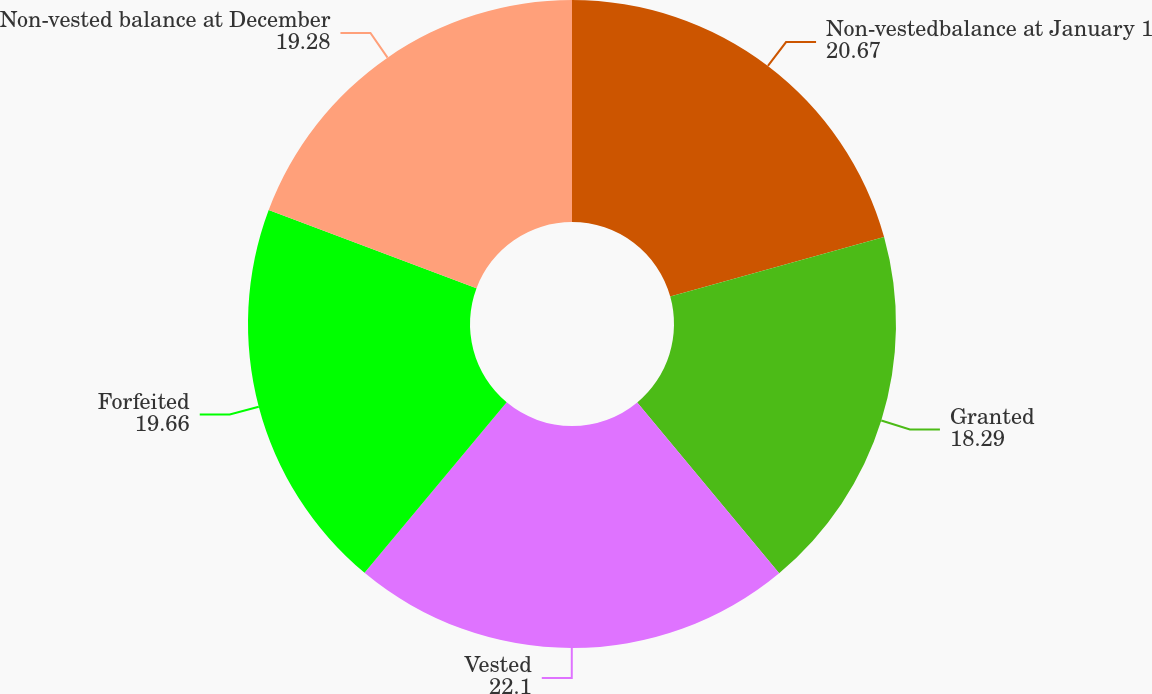<chart> <loc_0><loc_0><loc_500><loc_500><pie_chart><fcel>Non-vestedbalance at January 1<fcel>Granted<fcel>Vested<fcel>Forfeited<fcel>Non-vested balance at December<nl><fcel>20.67%<fcel>18.29%<fcel>22.1%<fcel>19.66%<fcel>19.28%<nl></chart> 